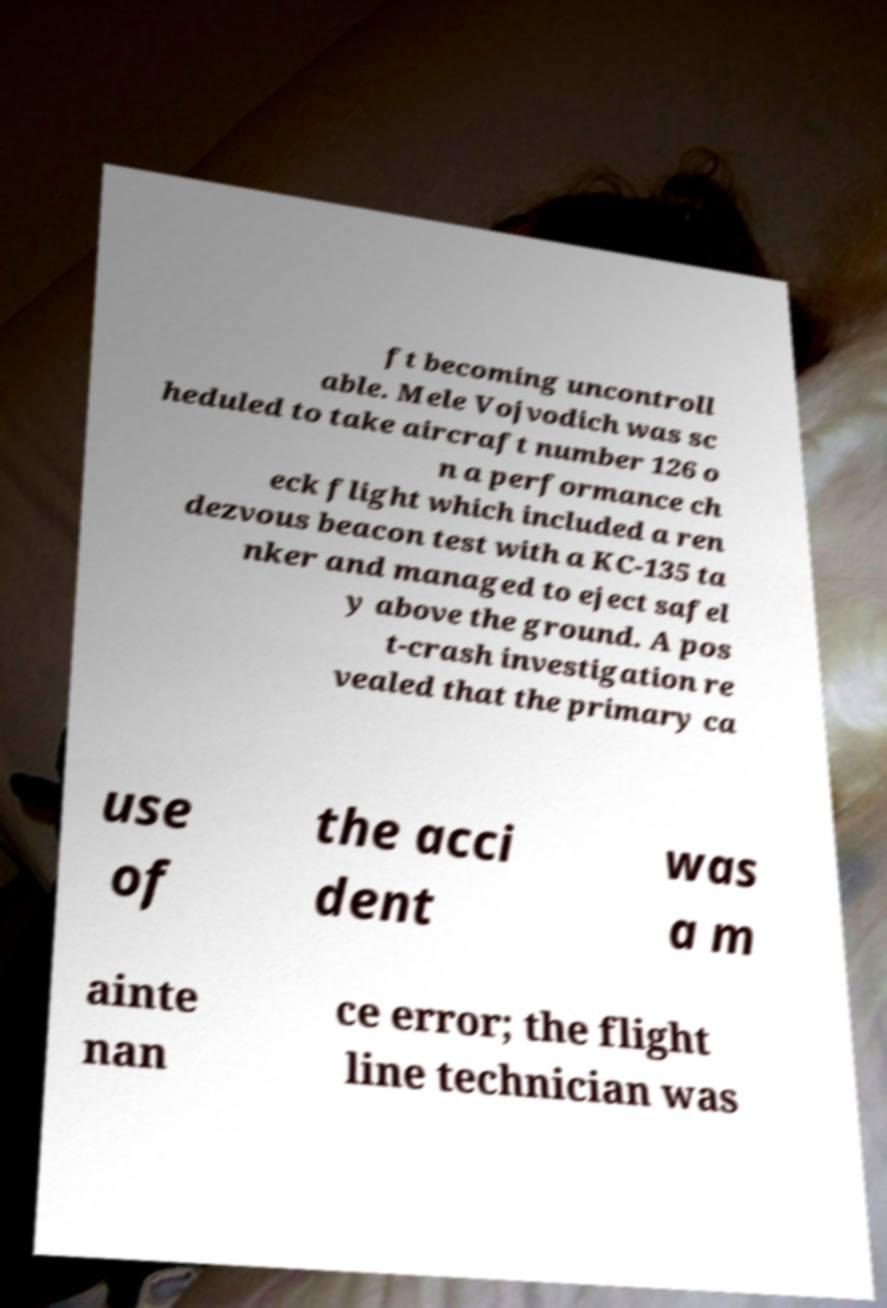Please read and relay the text visible in this image. What does it say? ft becoming uncontroll able. Mele Vojvodich was sc heduled to take aircraft number 126 o n a performance ch eck flight which included a ren dezvous beacon test with a KC-135 ta nker and managed to eject safel y above the ground. A pos t-crash investigation re vealed that the primary ca use of the acci dent was a m ainte nan ce error; the flight line technician was 